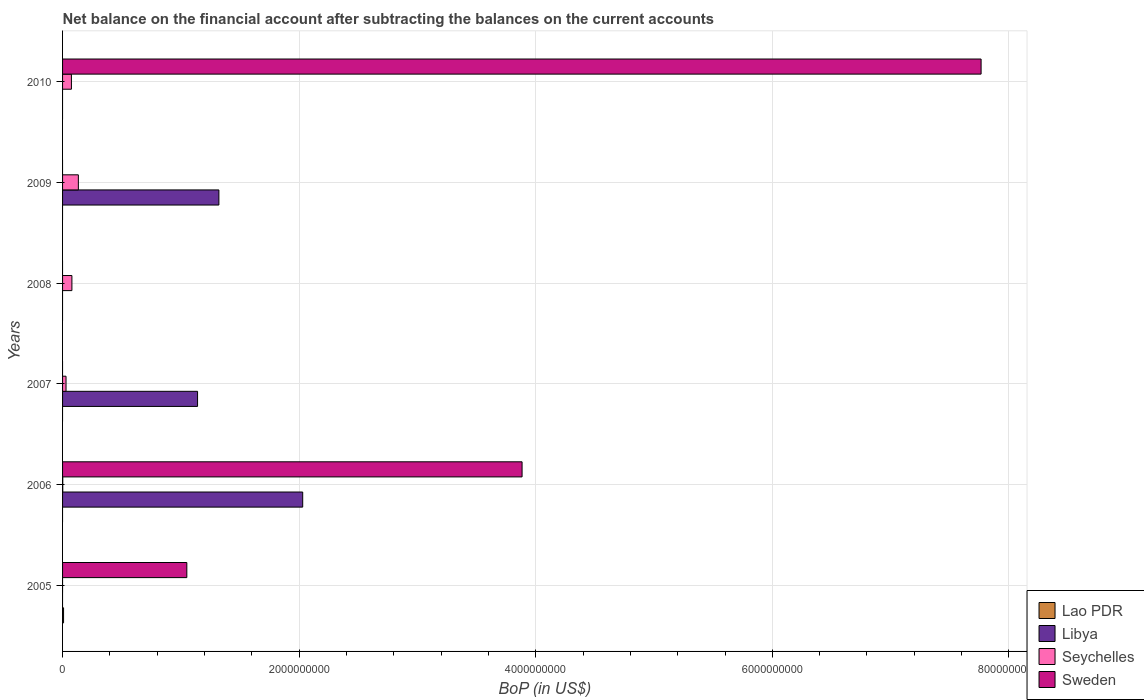Are the number of bars on each tick of the Y-axis equal?
Give a very brief answer. No. How many bars are there on the 5th tick from the top?
Keep it short and to the point. 3. What is the label of the 1st group of bars from the top?
Ensure brevity in your answer.  2010. In how many cases, is the number of bars for a given year not equal to the number of legend labels?
Your answer should be compact. 6. What is the Balance of Payments in Lao PDR in 2010?
Offer a very short reply. 0. Across all years, what is the maximum Balance of Payments in Lao PDR?
Make the answer very short. 8.44e+06. What is the total Balance of Payments in Libya in the graph?
Provide a short and direct response. 4.49e+09. What is the difference between the Balance of Payments in Seychelles in 2007 and that in 2010?
Make the answer very short. -4.55e+07. What is the difference between the Balance of Payments in Libya in 2006 and the Balance of Payments in Sweden in 2010?
Ensure brevity in your answer.  -5.73e+09. What is the average Balance of Payments in Lao PDR per year?
Your answer should be compact. 1.41e+06. In the year 2007, what is the difference between the Balance of Payments in Libya and Balance of Payments in Seychelles?
Make the answer very short. 1.11e+09. What is the ratio of the Balance of Payments in Libya in 2007 to that in 2009?
Your response must be concise. 0.86. Is the difference between the Balance of Payments in Libya in 2006 and 2007 greater than the difference between the Balance of Payments in Seychelles in 2006 and 2007?
Your answer should be compact. Yes. What is the difference between the highest and the second highest Balance of Payments in Seychelles?
Provide a short and direct response. 5.45e+07. What is the difference between the highest and the lowest Balance of Payments in Seychelles?
Make the answer very short. 1.33e+08. In how many years, is the Balance of Payments in Seychelles greater than the average Balance of Payments in Seychelles taken over all years?
Offer a terse response. 3. Is the sum of the Balance of Payments in Libya in 2006 and 2009 greater than the maximum Balance of Payments in Lao PDR across all years?
Your answer should be compact. Yes. Is it the case that in every year, the sum of the Balance of Payments in Lao PDR and Balance of Payments in Sweden is greater than the sum of Balance of Payments in Libya and Balance of Payments in Seychelles?
Your answer should be very brief. No. How many bars are there?
Your answer should be compact. 12. Are all the bars in the graph horizontal?
Provide a succinct answer. Yes. What is the difference between two consecutive major ticks on the X-axis?
Offer a terse response. 2.00e+09. Where does the legend appear in the graph?
Your answer should be very brief. Bottom right. How many legend labels are there?
Provide a succinct answer. 4. How are the legend labels stacked?
Make the answer very short. Vertical. What is the title of the graph?
Your answer should be compact. Net balance on the financial account after subtracting the balances on the current accounts. Does "Bahamas" appear as one of the legend labels in the graph?
Offer a terse response. No. What is the label or title of the X-axis?
Provide a short and direct response. BoP (in US$). What is the BoP (in US$) in Lao PDR in 2005?
Provide a succinct answer. 8.44e+06. What is the BoP (in US$) of Libya in 2005?
Provide a succinct answer. 0. What is the BoP (in US$) in Sweden in 2005?
Give a very brief answer. 1.05e+09. What is the BoP (in US$) in Lao PDR in 2006?
Ensure brevity in your answer.  0. What is the BoP (in US$) of Libya in 2006?
Your response must be concise. 2.03e+09. What is the BoP (in US$) of Seychelles in 2006?
Keep it short and to the point. 1.60e+06. What is the BoP (in US$) in Sweden in 2006?
Offer a very short reply. 3.88e+09. What is the BoP (in US$) in Libya in 2007?
Ensure brevity in your answer.  1.14e+09. What is the BoP (in US$) of Seychelles in 2007?
Offer a very short reply. 2.93e+07. What is the BoP (in US$) of Lao PDR in 2008?
Your answer should be compact. 0. What is the BoP (in US$) in Libya in 2008?
Give a very brief answer. 0. What is the BoP (in US$) of Seychelles in 2008?
Give a very brief answer. 7.90e+07. What is the BoP (in US$) of Sweden in 2008?
Offer a terse response. 0. What is the BoP (in US$) of Lao PDR in 2009?
Provide a short and direct response. 0. What is the BoP (in US$) in Libya in 2009?
Provide a short and direct response. 1.32e+09. What is the BoP (in US$) in Seychelles in 2009?
Your response must be concise. 1.33e+08. What is the BoP (in US$) in Sweden in 2009?
Offer a terse response. 0. What is the BoP (in US$) of Libya in 2010?
Keep it short and to the point. 0. What is the BoP (in US$) of Seychelles in 2010?
Give a very brief answer. 7.48e+07. What is the BoP (in US$) of Sweden in 2010?
Your answer should be compact. 7.76e+09. Across all years, what is the maximum BoP (in US$) in Lao PDR?
Keep it short and to the point. 8.44e+06. Across all years, what is the maximum BoP (in US$) of Libya?
Provide a short and direct response. 2.03e+09. Across all years, what is the maximum BoP (in US$) in Seychelles?
Provide a short and direct response. 1.33e+08. Across all years, what is the maximum BoP (in US$) in Sweden?
Provide a short and direct response. 7.76e+09. Across all years, what is the minimum BoP (in US$) in Libya?
Your answer should be compact. 0. Across all years, what is the minimum BoP (in US$) in Seychelles?
Make the answer very short. 0. What is the total BoP (in US$) of Lao PDR in the graph?
Make the answer very short. 8.44e+06. What is the total BoP (in US$) in Libya in the graph?
Keep it short and to the point. 4.49e+09. What is the total BoP (in US$) of Seychelles in the graph?
Your answer should be very brief. 3.18e+08. What is the total BoP (in US$) of Sweden in the graph?
Your answer should be very brief. 1.27e+1. What is the difference between the BoP (in US$) of Sweden in 2005 and that in 2006?
Give a very brief answer. -2.83e+09. What is the difference between the BoP (in US$) in Sweden in 2005 and that in 2010?
Provide a short and direct response. -6.71e+09. What is the difference between the BoP (in US$) of Libya in 2006 and that in 2007?
Offer a very short reply. 8.89e+08. What is the difference between the BoP (in US$) of Seychelles in 2006 and that in 2007?
Provide a succinct answer. -2.77e+07. What is the difference between the BoP (in US$) of Seychelles in 2006 and that in 2008?
Provide a short and direct response. -7.74e+07. What is the difference between the BoP (in US$) in Libya in 2006 and that in 2009?
Keep it short and to the point. 7.08e+08. What is the difference between the BoP (in US$) of Seychelles in 2006 and that in 2009?
Make the answer very short. -1.32e+08. What is the difference between the BoP (in US$) of Seychelles in 2006 and that in 2010?
Keep it short and to the point. -7.32e+07. What is the difference between the BoP (in US$) in Sweden in 2006 and that in 2010?
Keep it short and to the point. -3.88e+09. What is the difference between the BoP (in US$) of Seychelles in 2007 and that in 2008?
Your response must be concise. -4.97e+07. What is the difference between the BoP (in US$) in Libya in 2007 and that in 2009?
Provide a succinct answer. -1.80e+08. What is the difference between the BoP (in US$) of Seychelles in 2007 and that in 2009?
Your response must be concise. -1.04e+08. What is the difference between the BoP (in US$) of Seychelles in 2007 and that in 2010?
Provide a succinct answer. -4.55e+07. What is the difference between the BoP (in US$) of Seychelles in 2008 and that in 2009?
Your answer should be compact. -5.45e+07. What is the difference between the BoP (in US$) in Seychelles in 2008 and that in 2010?
Your response must be concise. 4.17e+06. What is the difference between the BoP (in US$) in Seychelles in 2009 and that in 2010?
Your answer should be compact. 5.86e+07. What is the difference between the BoP (in US$) in Lao PDR in 2005 and the BoP (in US$) in Libya in 2006?
Your answer should be compact. -2.02e+09. What is the difference between the BoP (in US$) of Lao PDR in 2005 and the BoP (in US$) of Seychelles in 2006?
Provide a succinct answer. 6.84e+06. What is the difference between the BoP (in US$) of Lao PDR in 2005 and the BoP (in US$) of Sweden in 2006?
Make the answer very short. -3.88e+09. What is the difference between the BoP (in US$) in Lao PDR in 2005 and the BoP (in US$) in Libya in 2007?
Provide a short and direct response. -1.13e+09. What is the difference between the BoP (in US$) of Lao PDR in 2005 and the BoP (in US$) of Seychelles in 2007?
Ensure brevity in your answer.  -2.09e+07. What is the difference between the BoP (in US$) of Lao PDR in 2005 and the BoP (in US$) of Seychelles in 2008?
Your answer should be very brief. -7.05e+07. What is the difference between the BoP (in US$) of Lao PDR in 2005 and the BoP (in US$) of Libya in 2009?
Your answer should be compact. -1.31e+09. What is the difference between the BoP (in US$) of Lao PDR in 2005 and the BoP (in US$) of Seychelles in 2009?
Your answer should be very brief. -1.25e+08. What is the difference between the BoP (in US$) of Lao PDR in 2005 and the BoP (in US$) of Seychelles in 2010?
Provide a succinct answer. -6.64e+07. What is the difference between the BoP (in US$) in Lao PDR in 2005 and the BoP (in US$) in Sweden in 2010?
Your answer should be compact. -7.76e+09. What is the difference between the BoP (in US$) in Libya in 2006 and the BoP (in US$) in Seychelles in 2007?
Your answer should be very brief. 2.00e+09. What is the difference between the BoP (in US$) of Libya in 2006 and the BoP (in US$) of Seychelles in 2008?
Keep it short and to the point. 1.95e+09. What is the difference between the BoP (in US$) in Libya in 2006 and the BoP (in US$) in Seychelles in 2009?
Provide a succinct answer. 1.90e+09. What is the difference between the BoP (in US$) in Libya in 2006 and the BoP (in US$) in Seychelles in 2010?
Provide a short and direct response. 1.96e+09. What is the difference between the BoP (in US$) in Libya in 2006 and the BoP (in US$) in Sweden in 2010?
Give a very brief answer. -5.73e+09. What is the difference between the BoP (in US$) in Seychelles in 2006 and the BoP (in US$) in Sweden in 2010?
Offer a very short reply. -7.76e+09. What is the difference between the BoP (in US$) in Libya in 2007 and the BoP (in US$) in Seychelles in 2008?
Ensure brevity in your answer.  1.06e+09. What is the difference between the BoP (in US$) of Libya in 2007 and the BoP (in US$) of Seychelles in 2009?
Your answer should be compact. 1.01e+09. What is the difference between the BoP (in US$) of Libya in 2007 and the BoP (in US$) of Seychelles in 2010?
Provide a short and direct response. 1.07e+09. What is the difference between the BoP (in US$) of Libya in 2007 and the BoP (in US$) of Sweden in 2010?
Provide a succinct answer. -6.62e+09. What is the difference between the BoP (in US$) of Seychelles in 2007 and the BoP (in US$) of Sweden in 2010?
Make the answer very short. -7.74e+09. What is the difference between the BoP (in US$) in Seychelles in 2008 and the BoP (in US$) in Sweden in 2010?
Your response must be concise. -7.69e+09. What is the difference between the BoP (in US$) of Libya in 2009 and the BoP (in US$) of Seychelles in 2010?
Offer a very short reply. 1.25e+09. What is the difference between the BoP (in US$) in Libya in 2009 and the BoP (in US$) in Sweden in 2010?
Provide a succinct answer. -6.44e+09. What is the difference between the BoP (in US$) in Seychelles in 2009 and the BoP (in US$) in Sweden in 2010?
Keep it short and to the point. -7.63e+09. What is the average BoP (in US$) of Lao PDR per year?
Provide a short and direct response. 1.41e+06. What is the average BoP (in US$) in Libya per year?
Provide a succinct answer. 7.49e+08. What is the average BoP (in US$) in Seychelles per year?
Offer a very short reply. 5.30e+07. What is the average BoP (in US$) of Sweden per year?
Keep it short and to the point. 2.12e+09. In the year 2005, what is the difference between the BoP (in US$) in Lao PDR and BoP (in US$) in Sweden?
Your answer should be compact. -1.04e+09. In the year 2006, what is the difference between the BoP (in US$) of Libya and BoP (in US$) of Seychelles?
Your answer should be compact. 2.03e+09. In the year 2006, what is the difference between the BoP (in US$) of Libya and BoP (in US$) of Sweden?
Offer a very short reply. -1.85e+09. In the year 2006, what is the difference between the BoP (in US$) in Seychelles and BoP (in US$) in Sweden?
Provide a succinct answer. -3.88e+09. In the year 2007, what is the difference between the BoP (in US$) in Libya and BoP (in US$) in Seychelles?
Your answer should be compact. 1.11e+09. In the year 2009, what is the difference between the BoP (in US$) in Libya and BoP (in US$) in Seychelles?
Ensure brevity in your answer.  1.19e+09. In the year 2010, what is the difference between the BoP (in US$) of Seychelles and BoP (in US$) of Sweden?
Keep it short and to the point. -7.69e+09. What is the ratio of the BoP (in US$) in Sweden in 2005 to that in 2006?
Give a very brief answer. 0.27. What is the ratio of the BoP (in US$) of Sweden in 2005 to that in 2010?
Offer a terse response. 0.14. What is the ratio of the BoP (in US$) of Libya in 2006 to that in 2007?
Your answer should be compact. 1.78. What is the ratio of the BoP (in US$) of Seychelles in 2006 to that in 2007?
Your response must be concise. 0.05. What is the ratio of the BoP (in US$) in Seychelles in 2006 to that in 2008?
Give a very brief answer. 0.02. What is the ratio of the BoP (in US$) of Libya in 2006 to that in 2009?
Provide a succinct answer. 1.54. What is the ratio of the BoP (in US$) in Seychelles in 2006 to that in 2009?
Your response must be concise. 0.01. What is the ratio of the BoP (in US$) in Seychelles in 2006 to that in 2010?
Keep it short and to the point. 0.02. What is the ratio of the BoP (in US$) of Sweden in 2006 to that in 2010?
Provide a short and direct response. 0.5. What is the ratio of the BoP (in US$) of Seychelles in 2007 to that in 2008?
Make the answer very short. 0.37. What is the ratio of the BoP (in US$) in Libya in 2007 to that in 2009?
Provide a short and direct response. 0.86. What is the ratio of the BoP (in US$) in Seychelles in 2007 to that in 2009?
Provide a succinct answer. 0.22. What is the ratio of the BoP (in US$) of Seychelles in 2007 to that in 2010?
Make the answer very short. 0.39. What is the ratio of the BoP (in US$) in Seychelles in 2008 to that in 2009?
Your answer should be very brief. 0.59. What is the ratio of the BoP (in US$) in Seychelles in 2008 to that in 2010?
Your response must be concise. 1.06. What is the ratio of the BoP (in US$) in Seychelles in 2009 to that in 2010?
Give a very brief answer. 1.78. What is the difference between the highest and the second highest BoP (in US$) of Libya?
Ensure brevity in your answer.  7.08e+08. What is the difference between the highest and the second highest BoP (in US$) of Seychelles?
Your answer should be very brief. 5.45e+07. What is the difference between the highest and the second highest BoP (in US$) of Sweden?
Provide a succinct answer. 3.88e+09. What is the difference between the highest and the lowest BoP (in US$) in Lao PDR?
Ensure brevity in your answer.  8.44e+06. What is the difference between the highest and the lowest BoP (in US$) of Libya?
Your answer should be very brief. 2.03e+09. What is the difference between the highest and the lowest BoP (in US$) in Seychelles?
Offer a terse response. 1.33e+08. What is the difference between the highest and the lowest BoP (in US$) of Sweden?
Your answer should be compact. 7.76e+09. 